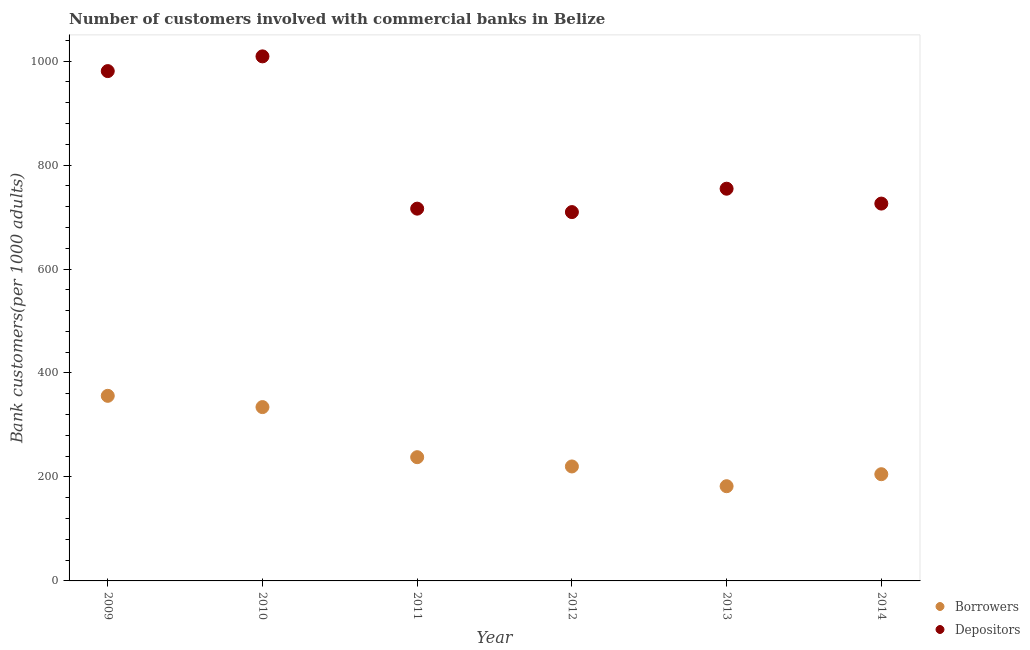How many different coloured dotlines are there?
Ensure brevity in your answer.  2. What is the number of depositors in 2014?
Your response must be concise. 725.9. Across all years, what is the maximum number of depositors?
Keep it short and to the point. 1009.11. Across all years, what is the minimum number of borrowers?
Provide a short and direct response. 182.21. In which year was the number of borrowers maximum?
Provide a short and direct response. 2009. In which year was the number of borrowers minimum?
Your answer should be compact. 2013. What is the total number of depositors in the graph?
Your answer should be compact. 4896.01. What is the difference between the number of borrowers in 2010 and that in 2012?
Your answer should be compact. 114.2. What is the difference between the number of borrowers in 2011 and the number of depositors in 2009?
Your answer should be compact. -742.73. What is the average number of borrowers per year?
Make the answer very short. 256.04. In the year 2013, what is the difference between the number of depositors and number of borrowers?
Provide a succinct answer. 572.32. In how many years, is the number of depositors greater than 480?
Offer a very short reply. 6. What is the ratio of the number of depositors in 2011 to that in 2013?
Provide a succinct answer. 0.95. Is the difference between the number of depositors in 2011 and 2012 greater than the difference between the number of borrowers in 2011 and 2012?
Offer a very short reply. No. What is the difference between the highest and the second highest number of depositors?
Keep it short and to the point. 28.34. What is the difference between the highest and the lowest number of depositors?
Ensure brevity in your answer.  299.57. Is the sum of the number of depositors in 2009 and 2014 greater than the maximum number of borrowers across all years?
Offer a very short reply. Yes. Does the number of depositors monotonically increase over the years?
Provide a succinct answer. No. Is the number of depositors strictly greater than the number of borrowers over the years?
Keep it short and to the point. Yes. What is the difference between two consecutive major ticks on the Y-axis?
Ensure brevity in your answer.  200. Does the graph contain any zero values?
Offer a very short reply. No. Does the graph contain grids?
Provide a succinct answer. No. Where does the legend appear in the graph?
Offer a terse response. Bottom right. How many legend labels are there?
Your answer should be compact. 2. How are the legend labels stacked?
Provide a succinct answer. Vertical. What is the title of the graph?
Give a very brief answer. Number of customers involved with commercial banks in Belize. Does "Frequency of shipment arrival" appear as one of the legend labels in the graph?
Provide a short and direct response. No. What is the label or title of the Y-axis?
Your answer should be compact. Bank customers(per 1000 adults). What is the Bank customers(per 1000 adults) of Borrowers in 2009?
Your answer should be very brief. 356.07. What is the Bank customers(per 1000 adults) of Depositors in 2009?
Ensure brevity in your answer.  980.77. What is the Bank customers(per 1000 adults) of Borrowers in 2010?
Make the answer very short. 334.41. What is the Bank customers(per 1000 adults) in Depositors in 2010?
Your answer should be compact. 1009.11. What is the Bank customers(per 1000 adults) of Borrowers in 2011?
Provide a short and direct response. 238.05. What is the Bank customers(per 1000 adults) in Depositors in 2011?
Provide a succinct answer. 716.16. What is the Bank customers(per 1000 adults) in Borrowers in 2012?
Your response must be concise. 220.2. What is the Bank customers(per 1000 adults) of Depositors in 2012?
Your response must be concise. 709.54. What is the Bank customers(per 1000 adults) in Borrowers in 2013?
Your answer should be compact. 182.21. What is the Bank customers(per 1000 adults) of Depositors in 2013?
Keep it short and to the point. 754.53. What is the Bank customers(per 1000 adults) in Borrowers in 2014?
Your answer should be compact. 205.29. What is the Bank customers(per 1000 adults) in Depositors in 2014?
Offer a very short reply. 725.9. Across all years, what is the maximum Bank customers(per 1000 adults) in Borrowers?
Keep it short and to the point. 356.07. Across all years, what is the maximum Bank customers(per 1000 adults) of Depositors?
Make the answer very short. 1009.11. Across all years, what is the minimum Bank customers(per 1000 adults) in Borrowers?
Keep it short and to the point. 182.21. Across all years, what is the minimum Bank customers(per 1000 adults) in Depositors?
Keep it short and to the point. 709.54. What is the total Bank customers(per 1000 adults) of Borrowers in the graph?
Provide a short and direct response. 1536.23. What is the total Bank customers(per 1000 adults) of Depositors in the graph?
Provide a succinct answer. 4896.01. What is the difference between the Bank customers(per 1000 adults) in Borrowers in 2009 and that in 2010?
Offer a terse response. 21.67. What is the difference between the Bank customers(per 1000 adults) in Depositors in 2009 and that in 2010?
Keep it short and to the point. -28.34. What is the difference between the Bank customers(per 1000 adults) of Borrowers in 2009 and that in 2011?
Make the answer very short. 118.03. What is the difference between the Bank customers(per 1000 adults) in Depositors in 2009 and that in 2011?
Offer a terse response. 264.62. What is the difference between the Bank customers(per 1000 adults) of Borrowers in 2009 and that in 2012?
Give a very brief answer. 135.87. What is the difference between the Bank customers(per 1000 adults) of Depositors in 2009 and that in 2012?
Give a very brief answer. 271.24. What is the difference between the Bank customers(per 1000 adults) in Borrowers in 2009 and that in 2013?
Provide a short and direct response. 173.87. What is the difference between the Bank customers(per 1000 adults) in Depositors in 2009 and that in 2013?
Your response must be concise. 226.24. What is the difference between the Bank customers(per 1000 adults) of Borrowers in 2009 and that in 2014?
Ensure brevity in your answer.  150.78. What is the difference between the Bank customers(per 1000 adults) of Depositors in 2009 and that in 2014?
Your answer should be compact. 254.87. What is the difference between the Bank customers(per 1000 adults) of Borrowers in 2010 and that in 2011?
Offer a terse response. 96.36. What is the difference between the Bank customers(per 1000 adults) in Depositors in 2010 and that in 2011?
Your answer should be very brief. 292.95. What is the difference between the Bank customers(per 1000 adults) of Borrowers in 2010 and that in 2012?
Give a very brief answer. 114.2. What is the difference between the Bank customers(per 1000 adults) of Depositors in 2010 and that in 2012?
Keep it short and to the point. 299.57. What is the difference between the Bank customers(per 1000 adults) of Borrowers in 2010 and that in 2013?
Provide a short and direct response. 152.2. What is the difference between the Bank customers(per 1000 adults) of Depositors in 2010 and that in 2013?
Ensure brevity in your answer.  254.58. What is the difference between the Bank customers(per 1000 adults) of Borrowers in 2010 and that in 2014?
Your answer should be very brief. 129.11. What is the difference between the Bank customers(per 1000 adults) of Depositors in 2010 and that in 2014?
Offer a terse response. 283.21. What is the difference between the Bank customers(per 1000 adults) of Borrowers in 2011 and that in 2012?
Offer a very short reply. 17.84. What is the difference between the Bank customers(per 1000 adults) of Depositors in 2011 and that in 2012?
Make the answer very short. 6.62. What is the difference between the Bank customers(per 1000 adults) of Borrowers in 2011 and that in 2013?
Offer a very short reply. 55.84. What is the difference between the Bank customers(per 1000 adults) of Depositors in 2011 and that in 2013?
Offer a very short reply. -38.37. What is the difference between the Bank customers(per 1000 adults) in Borrowers in 2011 and that in 2014?
Keep it short and to the point. 32.75. What is the difference between the Bank customers(per 1000 adults) in Depositors in 2011 and that in 2014?
Your answer should be very brief. -9.74. What is the difference between the Bank customers(per 1000 adults) of Borrowers in 2012 and that in 2013?
Make the answer very short. 38. What is the difference between the Bank customers(per 1000 adults) of Depositors in 2012 and that in 2013?
Provide a short and direct response. -44.99. What is the difference between the Bank customers(per 1000 adults) of Borrowers in 2012 and that in 2014?
Your response must be concise. 14.91. What is the difference between the Bank customers(per 1000 adults) in Depositors in 2012 and that in 2014?
Ensure brevity in your answer.  -16.36. What is the difference between the Bank customers(per 1000 adults) in Borrowers in 2013 and that in 2014?
Give a very brief answer. -23.09. What is the difference between the Bank customers(per 1000 adults) of Depositors in 2013 and that in 2014?
Make the answer very short. 28.63. What is the difference between the Bank customers(per 1000 adults) in Borrowers in 2009 and the Bank customers(per 1000 adults) in Depositors in 2010?
Your response must be concise. -653.04. What is the difference between the Bank customers(per 1000 adults) of Borrowers in 2009 and the Bank customers(per 1000 adults) of Depositors in 2011?
Make the answer very short. -360.09. What is the difference between the Bank customers(per 1000 adults) of Borrowers in 2009 and the Bank customers(per 1000 adults) of Depositors in 2012?
Provide a short and direct response. -353.46. What is the difference between the Bank customers(per 1000 adults) in Borrowers in 2009 and the Bank customers(per 1000 adults) in Depositors in 2013?
Offer a very short reply. -398.46. What is the difference between the Bank customers(per 1000 adults) in Borrowers in 2009 and the Bank customers(per 1000 adults) in Depositors in 2014?
Your response must be concise. -369.83. What is the difference between the Bank customers(per 1000 adults) of Borrowers in 2010 and the Bank customers(per 1000 adults) of Depositors in 2011?
Make the answer very short. -381.75. What is the difference between the Bank customers(per 1000 adults) of Borrowers in 2010 and the Bank customers(per 1000 adults) of Depositors in 2012?
Give a very brief answer. -375.13. What is the difference between the Bank customers(per 1000 adults) in Borrowers in 2010 and the Bank customers(per 1000 adults) in Depositors in 2013?
Offer a terse response. -420.12. What is the difference between the Bank customers(per 1000 adults) of Borrowers in 2010 and the Bank customers(per 1000 adults) of Depositors in 2014?
Your answer should be very brief. -391.49. What is the difference between the Bank customers(per 1000 adults) in Borrowers in 2011 and the Bank customers(per 1000 adults) in Depositors in 2012?
Offer a terse response. -471.49. What is the difference between the Bank customers(per 1000 adults) in Borrowers in 2011 and the Bank customers(per 1000 adults) in Depositors in 2013?
Give a very brief answer. -516.48. What is the difference between the Bank customers(per 1000 adults) in Borrowers in 2011 and the Bank customers(per 1000 adults) in Depositors in 2014?
Ensure brevity in your answer.  -487.86. What is the difference between the Bank customers(per 1000 adults) in Borrowers in 2012 and the Bank customers(per 1000 adults) in Depositors in 2013?
Provide a succinct answer. -534.33. What is the difference between the Bank customers(per 1000 adults) of Borrowers in 2012 and the Bank customers(per 1000 adults) of Depositors in 2014?
Your answer should be very brief. -505.7. What is the difference between the Bank customers(per 1000 adults) in Borrowers in 2013 and the Bank customers(per 1000 adults) in Depositors in 2014?
Keep it short and to the point. -543.69. What is the average Bank customers(per 1000 adults) in Borrowers per year?
Offer a terse response. 256.04. What is the average Bank customers(per 1000 adults) of Depositors per year?
Provide a short and direct response. 816. In the year 2009, what is the difference between the Bank customers(per 1000 adults) of Borrowers and Bank customers(per 1000 adults) of Depositors?
Provide a succinct answer. -624.7. In the year 2010, what is the difference between the Bank customers(per 1000 adults) of Borrowers and Bank customers(per 1000 adults) of Depositors?
Provide a succinct answer. -674.71. In the year 2011, what is the difference between the Bank customers(per 1000 adults) in Borrowers and Bank customers(per 1000 adults) in Depositors?
Your response must be concise. -478.11. In the year 2012, what is the difference between the Bank customers(per 1000 adults) in Borrowers and Bank customers(per 1000 adults) in Depositors?
Ensure brevity in your answer.  -489.33. In the year 2013, what is the difference between the Bank customers(per 1000 adults) in Borrowers and Bank customers(per 1000 adults) in Depositors?
Ensure brevity in your answer.  -572.32. In the year 2014, what is the difference between the Bank customers(per 1000 adults) of Borrowers and Bank customers(per 1000 adults) of Depositors?
Give a very brief answer. -520.61. What is the ratio of the Bank customers(per 1000 adults) of Borrowers in 2009 to that in 2010?
Give a very brief answer. 1.06. What is the ratio of the Bank customers(per 1000 adults) of Depositors in 2009 to that in 2010?
Your answer should be very brief. 0.97. What is the ratio of the Bank customers(per 1000 adults) of Borrowers in 2009 to that in 2011?
Provide a short and direct response. 1.5. What is the ratio of the Bank customers(per 1000 adults) in Depositors in 2009 to that in 2011?
Your response must be concise. 1.37. What is the ratio of the Bank customers(per 1000 adults) of Borrowers in 2009 to that in 2012?
Make the answer very short. 1.62. What is the ratio of the Bank customers(per 1000 adults) of Depositors in 2009 to that in 2012?
Provide a succinct answer. 1.38. What is the ratio of the Bank customers(per 1000 adults) in Borrowers in 2009 to that in 2013?
Your answer should be compact. 1.95. What is the ratio of the Bank customers(per 1000 adults) in Depositors in 2009 to that in 2013?
Offer a terse response. 1.3. What is the ratio of the Bank customers(per 1000 adults) of Borrowers in 2009 to that in 2014?
Provide a short and direct response. 1.73. What is the ratio of the Bank customers(per 1000 adults) in Depositors in 2009 to that in 2014?
Your answer should be very brief. 1.35. What is the ratio of the Bank customers(per 1000 adults) of Borrowers in 2010 to that in 2011?
Keep it short and to the point. 1.4. What is the ratio of the Bank customers(per 1000 adults) in Depositors in 2010 to that in 2011?
Make the answer very short. 1.41. What is the ratio of the Bank customers(per 1000 adults) in Borrowers in 2010 to that in 2012?
Offer a terse response. 1.52. What is the ratio of the Bank customers(per 1000 adults) in Depositors in 2010 to that in 2012?
Offer a terse response. 1.42. What is the ratio of the Bank customers(per 1000 adults) of Borrowers in 2010 to that in 2013?
Offer a very short reply. 1.84. What is the ratio of the Bank customers(per 1000 adults) in Depositors in 2010 to that in 2013?
Make the answer very short. 1.34. What is the ratio of the Bank customers(per 1000 adults) in Borrowers in 2010 to that in 2014?
Provide a succinct answer. 1.63. What is the ratio of the Bank customers(per 1000 adults) in Depositors in 2010 to that in 2014?
Your answer should be very brief. 1.39. What is the ratio of the Bank customers(per 1000 adults) of Borrowers in 2011 to that in 2012?
Make the answer very short. 1.08. What is the ratio of the Bank customers(per 1000 adults) in Depositors in 2011 to that in 2012?
Provide a succinct answer. 1.01. What is the ratio of the Bank customers(per 1000 adults) of Borrowers in 2011 to that in 2013?
Provide a succinct answer. 1.31. What is the ratio of the Bank customers(per 1000 adults) of Depositors in 2011 to that in 2013?
Ensure brevity in your answer.  0.95. What is the ratio of the Bank customers(per 1000 adults) in Borrowers in 2011 to that in 2014?
Keep it short and to the point. 1.16. What is the ratio of the Bank customers(per 1000 adults) in Depositors in 2011 to that in 2014?
Your answer should be very brief. 0.99. What is the ratio of the Bank customers(per 1000 adults) of Borrowers in 2012 to that in 2013?
Keep it short and to the point. 1.21. What is the ratio of the Bank customers(per 1000 adults) of Depositors in 2012 to that in 2013?
Ensure brevity in your answer.  0.94. What is the ratio of the Bank customers(per 1000 adults) in Borrowers in 2012 to that in 2014?
Provide a short and direct response. 1.07. What is the ratio of the Bank customers(per 1000 adults) in Depositors in 2012 to that in 2014?
Your response must be concise. 0.98. What is the ratio of the Bank customers(per 1000 adults) of Borrowers in 2013 to that in 2014?
Provide a short and direct response. 0.89. What is the ratio of the Bank customers(per 1000 adults) of Depositors in 2013 to that in 2014?
Your answer should be compact. 1.04. What is the difference between the highest and the second highest Bank customers(per 1000 adults) in Borrowers?
Offer a terse response. 21.67. What is the difference between the highest and the second highest Bank customers(per 1000 adults) of Depositors?
Provide a short and direct response. 28.34. What is the difference between the highest and the lowest Bank customers(per 1000 adults) in Borrowers?
Your response must be concise. 173.87. What is the difference between the highest and the lowest Bank customers(per 1000 adults) in Depositors?
Provide a short and direct response. 299.57. 